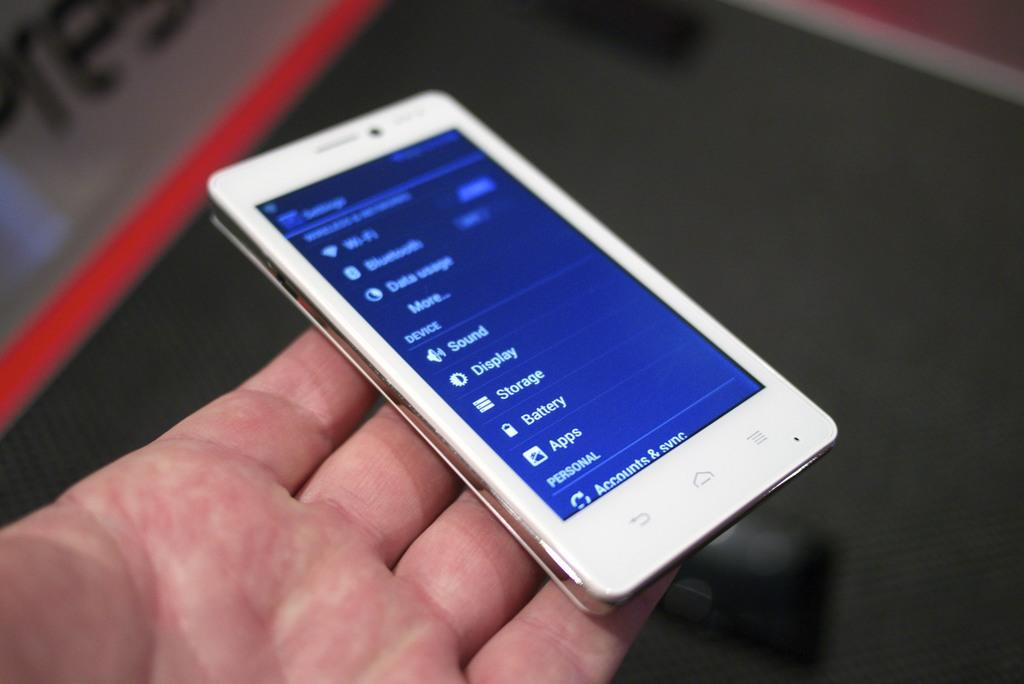<image>
Relay a brief, clear account of the picture shown. A white cellphone displaying the settings menu on its screen with options like sound and display. 